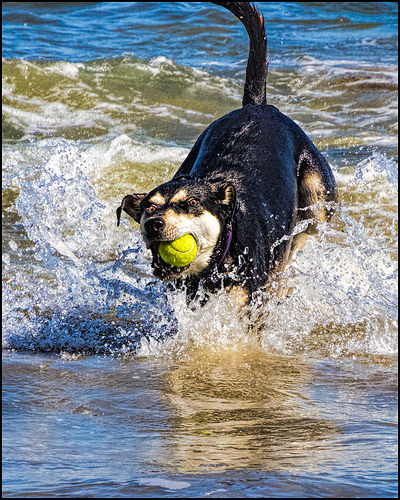<image>
Is there a tennis ball above the water? Yes. The tennis ball is positioned above the water in the vertical space, higher up in the scene. 